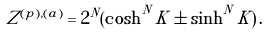Convert formula to latex. <formula><loc_0><loc_0><loc_500><loc_500>Z ^ { ( p ) , ( a ) } = 2 ^ { N } ( \cosh ^ { N } { K } \pm \sinh ^ { N } { K } ) \, .</formula> 